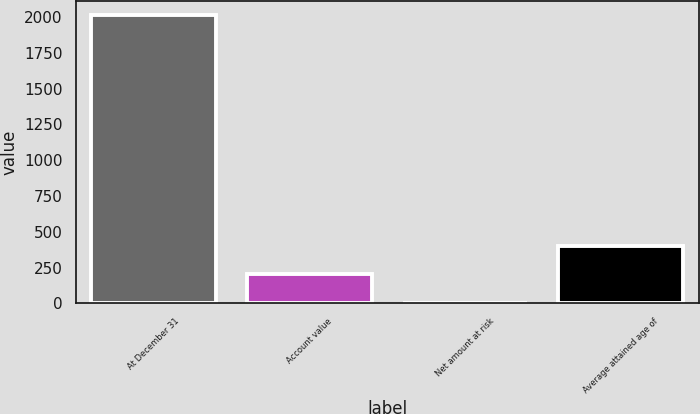<chart> <loc_0><loc_0><loc_500><loc_500><bar_chart><fcel>At December 31<fcel>Account value<fcel>Net amount at risk<fcel>Average attained age of<nl><fcel>2013<fcel>202.2<fcel>1<fcel>403.4<nl></chart> 